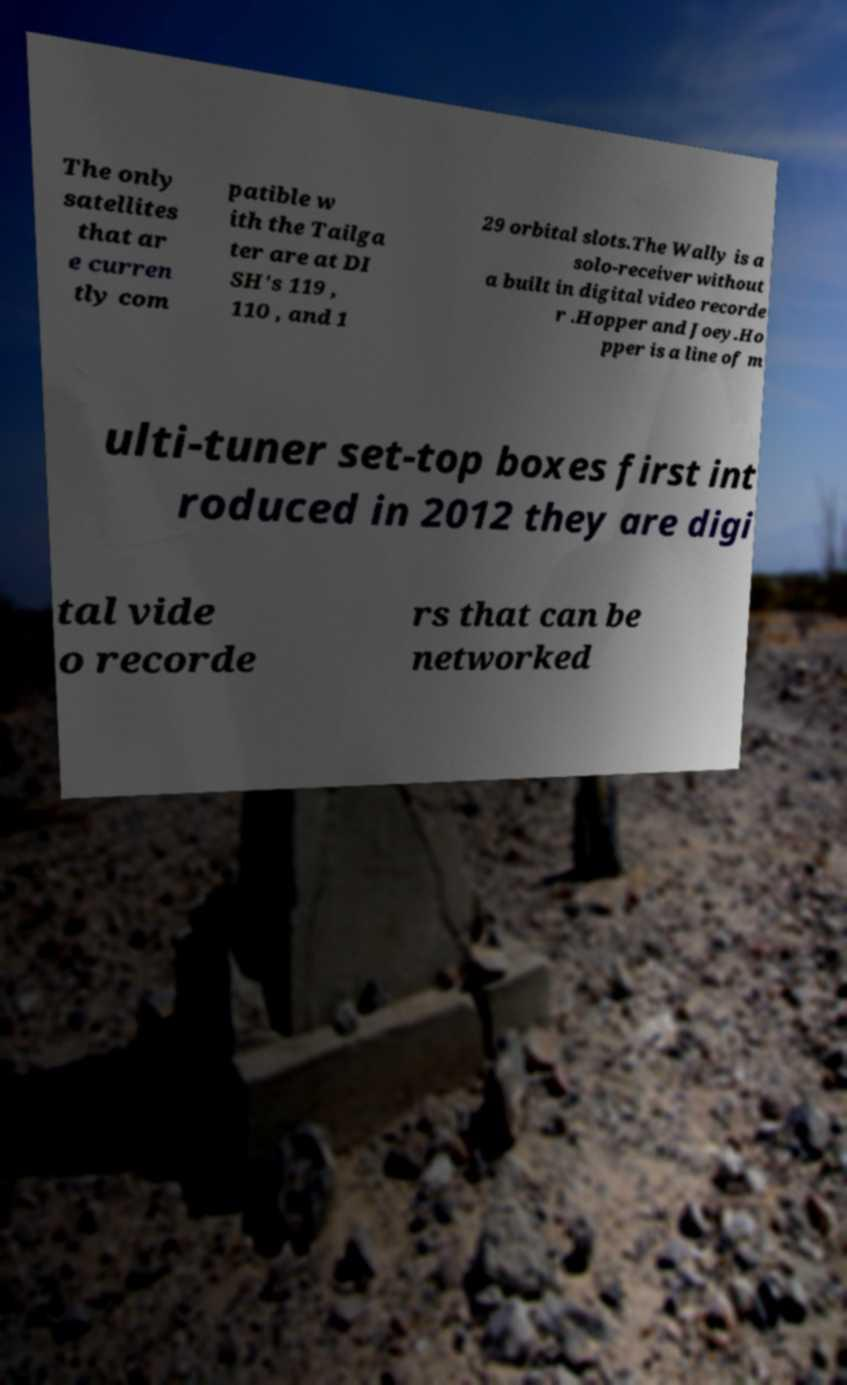What messages or text are displayed in this image? I need them in a readable, typed format. The only satellites that ar e curren tly com patible w ith the Tailga ter are at DI SH's 119 , 110 , and 1 29 orbital slots.The Wally is a solo-receiver without a built in digital video recorde r .Hopper and Joey.Ho pper is a line of m ulti-tuner set-top boxes first int roduced in 2012 they are digi tal vide o recorde rs that can be networked 